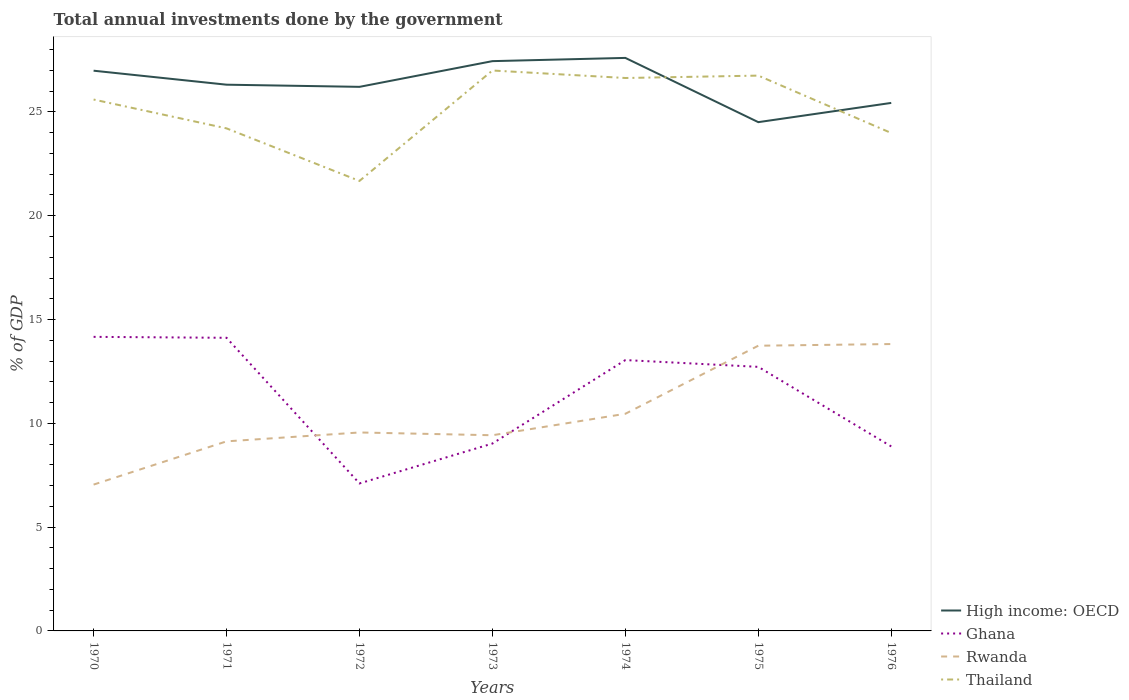Across all years, what is the maximum total annual investments done by the government in Rwanda?
Your response must be concise. 7.05. In which year was the total annual investments done by the government in High income: OECD maximum?
Your response must be concise. 1975. What is the total total annual investments done by the government in Rwanda in the graph?
Your response must be concise. -2.51. What is the difference between the highest and the second highest total annual investments done by the government in Thailand?
Make the answer very short. 5.32. What is the difference between the highest and the lowest total annual investments done by the government in Thailand?
Provide a succinct answer. 4. How many years are there in the graph?
Your response must be concise. 7. Are the values on the major ticks of Y-axis written in scientific E-notation?
Offer a very short reply. No. Does the graph contain grids?
Offer a very short reply. No. How many legend labels are there?
Provide a short and direct response. 4. How are the legend labels stacked?
Your answer should be compact. Vertical. What is the title of the graph?
Ensure brevity in your answer.  Total annual investments done by the government. What is the label or title of the Y-axis?
Your answer should be compact. % of GDP. What is the % of GDP of High income: OECD in 1970?
Your answer should be very brief. 26.99. What is the % of GDP in Ghana in 1970?
Give a very brief answer. 14.17. What is the % of GDP of Rwanda in 1970?
Make the answer very short. 7.05. What is the % of GDP in Thailand in 1970?
Give a very brief answer. 25.6. What is the % of GDP of High income: OECD in 1971?
Your response must be concise. 26.31. What is the % of GDP in Ghana in 1971?
Keep it short and to the point. 14.12. What is the % of GDP in Rwanda in 1971?
Your response must be concise. 9.13. What is the % of GDP of Thailand in 1971?
Ensure brevity in your answer.  24.21. What is the % of GDP of High income: OECD in 1972?
Your answer should be very brief. 26.21. What is the % of GDP of Ghana in 1972?
Provide a short and direct response. 7.1. What is the % of GDP in Rwanda in 1972?
Offer a terse response. 9.56. What is the % of GDP in Thailand in 1972?
Offer a terse response. 21.68. What is the % of GDP of High income: OECD in 1973?
Provide a succinct answer. 27.45. What is the % of GDP in Ghana in 1973?
Offer a terse response. 9.03. What is the % of GDP in Rwanda in 1973?
Ensure brevity in your answer.  9.43. What is the % of GDP in Thailand in 1973?
Your answer should be very brief. 27. What is the % of GDP in High income: OECD in 1974?
Offer a terse response. 27.6. What is the % of GDP in Ghana in 1974?
Ensure brevity in your answer.  13.05. What is the % of GDP of Rwanda in 1974?
Keep it short and to the point. 10.46. What is the % of GDP of Thailand in 1974?
Give a very brief answer. 26.64. What is the % of GDP of High income: OECD in 1975?
Provide a succinct answer. 24.51. What is the % of GDP of Ghana in 1975?
Your answer should be very brief. 12.72. What is the % of GDP in Rwanda in 1975?
Your answer should be very brief. 13.74. What is the % of GDP of Thailand in 1975?
Your answer should be very brief. 26.75. What is the % of GDP in High income: OECD in 1976?
Offer a very short reply. 25.43. What is the % of GDP of Ghana in 1976?
Your answer should be very brief. 8.89. What is the % of GDP of Rwanda in 1976?
Offer a terse response. 13.82. What is the % of GDP in Thailand in 1976?
Give a very brief answer. 23.99. Across all years, what is the maximum % of GDP of High income: OECD?
Give a very brief answer. 27.6. Across all years, what is the maximum % of GDP in Ghana?
Make the answer very short. 14.17. Across all years, what is the maximum % of GDP in Rwanda?
Offer a very short reply. 13.82. Across all years, what is the maximum % of GDP of Thailand?
Your response must be concise. 27. Across all years, what is the minimum % of GDP in High income: OECD?
Give a very brief answer. 24.51. Across all years, what is the minimum % of GDP in Ghana?
Provide a succinct answer. 7.1. Across all years, what is the minimum % of GDP of Rwanda?
Your answer should be compact. 7.05. Across all years, what is the minimum % of GDP of Thailand?
Your response must be concise. 21.68. What is the total % of GDP in High income: OECD in the graph?
Your answer should be compact. 184.5. What is the total % of GDP of Ghana in the graph?
Provide a short and direct response. 79.07. What is the total % of GDP of Rwanda in the graph?
Offer a very short reply. 73.18. What is the total % of GDP in Thailand in the graph?
Keep it short and to the point. 175.85. What is the difference between the % of GDP in High income: OECD in 1970 and that in 1971?
Offer a very short reply. 0.67. What is the difference between the % of GDP in Ghana in 1970 and that in 1971?
Offer a very short reply. 0.05. What is the difference between the % of GDP of Rwanda in 1970 and that in 1971?
Ensure brevity in your answer.  -2.08. What is the difference between the % of GDP in Thailand in 1970 and that in 1971?
Offer a very short reply. 1.39. What is the difference between the % of GDP in High income: OECD in 1970 and that in 1972?
Your answer should be very brief. 0.78. What is the difference between the % of GDP of Ghana in 1970 and that in 1972?
Your response must be concise. 7.06. What is the difference between the % of GDP of Rwanda in 1970 and that in 1972?
Provide a succinct answer. -2.51. What is the difference between the % of GDP in Thailand in 1970 and that in 1972?
Offer a terse response. 3.92. What is the difference between the % of GDP in High income: OECD in 1970 and that in 1973?
Provide a short and direct response. -0.46. What is the difference between the % of GDP of Ghana in 1970 and that in 1973?
Offer a very short reply. 5.14. What is the difference between the % of GDP of Rwanda in 1970 and that in 1973?
Give a very brief answer. -2.38. What is the difference between the % of GDP in Thailand in 1970 and that in 1973?
Your answer should be compact. -1.4. What is the difference between the % of GDP of High income: OECD in 1970 and that in 1974?
Your answer should be very brief. -0.62. What is the difference between the % of GDP in Ghana in 1970 and that in 1974?
Keep it short and to the point. 1.12. What is the difference between the % of GDP of Rwanda in 1970 and that in 1974?
Offer a terse response. -3.41. What is the difference between the % of GDP in Thailand in 1970 and that in 1974?
Your answer should be very brief. -1.04. What is the difference between the % of GDP in High income: OECD in 1970 and that in 1975?
Give a very brief answer. 2.48. What is the difference between the % of GDP of Ghana in 1970 and that in 1975?
Your response must be concise. 1.45. What is the difference between the % of GDP of Rwanda in 1970 and that in 1975?
Offer a terse response. -6.69. What is the difference between the % of GDP in Thailand in 1970 and that in 1975?
Your answer should be compact. -1.15. What is the difference between the % of GDP of High income: OECD in 1970 and that in 1976?
Provide a short and direct response. 1.55. What is the difference between the % of GDP of Ghana in 1970 and that in 1976?
Provide a succinct answer. 5.28. What is the difference between the % of GDP in Rwanda in 1970 and that in 1976?
Provide a short and direct response. -6.77. What is the difference between the % of GDP in Thailand in 1970 and that in 1976?
Keep it short and to the point. 1.61. What is the difference between the % of GDP of High income: OECD in 1971 and that in 1972?
Provide a short and direct response. 0.1. What is the difference between the % of GDP in Ghana in 1971 and that in 1972?
Keep it short and to the point. 7.02. What is the difference between the % of GDP in Rwanda in 1971 and that in 1972?
Your answer should be compact. -0.43. What is the difference between the % of GDP of Thailand in 1971 and that in 1972?
Give a very brief answer. 2.53. What is the difference between the % of GDP in High income: OECD in 1971 and that in 1973?
Your response must be concise. -1.13. What is the difference between the % of GDP in Ghana in 1971 and that in 1973?
Offer a very short reply. 5.09. What is the difference between the % of GDP of Rwanda in 1971 and that in 1973?
Provide a short and direct response. -0.29. What is the difference between the % of GDP in Thailand in 1971 and that in 1973?
Provide a succinct answer. -2.79. What is the difference between the % of GDP in High income: OECD in 1971 and that in 1974?
Offer a very short reply. -1.29. What is the difference between the % of GDP of Ghana in 1971 and that in 1974?
Provide a succinct answer. 1.07. What is the difference between the % of GDP of Rwanda in 1971 and that in 1974?
Ensure brevity in your answer.  -1.33. What is the difference between the % of GDP in Thailand in 1971 and that in 1974?
Provide a short and direct response. -2.43. What is the difference between the % of GDP in High income: OECD in 1971 and that in 1975?
Offer a very short reply. 1.8. What is the difference between the % of GDP of Rwanda in 1971 and that in 1975?
Keep it short and to the point. -4.61. What is the difference between the % of GDP of Thailand in 1971 and that in 1975?
Offer a terse response. -2.54. What is the difference between the % of GDP in High income: OECD in 1971 and that in 1976?
Your answer should be compact. 0.88. What is the difference between the % of GDP of Ghana in 1971 and that in 1976?
Provide a short and direct response. 5.23. What is the difference between the % of GDP of Rwanda in 1971 and that in 1976?
Your response must be concise. -4.69. What is the difference between the % of GDP of Thailand in 1971 and that in 1976?
Make the answer very short. 0.22. What is the difference between the % of GDP in High income: OECD in 1972 and that in 1973?
Make the answer very short. -1.24. What is the difference between the % of GDP in Ghana in 1972 and that in 1973?
Provide a succinct answer. -1.92. What is the difference between the % of GDP in Rwanda in 1972 and that in 1973?
Keep it short and to the point. 0.13. What is the difference between the % of GDP in Thailand in 1972 and that in 1973?
Make the answer very short. -5.32. What is the difference between the % of GDP in High income: OECD in 1972 and that in 1974?
Your answer should be compact. -1.39. What is the difference between the % of GDP of Ghana in 1972 and that in 1974?
Offer a very short reply. -5.94. What is the difference between the % of GDP in Rwanda in 1972 and that in 1974?
Provide a short and direct response. -0.9. What is the difference between the % of GDP in Thailand in 1972 and that in 1974?
Offer a terse response. -4.96. What is the difference between the % of GDP in High income: OECD in 1972 and that in 1975?
Your answer should be compact. 1.7. What is the difference between the % of GDP in Ghana in 1972 and that in 1975?
Your answer should be very brief. -5.62. What is the difference between the % of GDP of Rwanda in 1972 and that in 1975?
Give a very brief answer. -4.18. What is the difference between the % of GDP in Thailand in 1972 and that in 1975?
Provide a succinct answer. -5.07. What is the difference between the % of GDP of High income: OECD in 1972 and that in 1976?
Provide a short and direct response. 0.77. What is the difference between the % of GDP of Ghana in 1972 and that in 1976?
Provide a short and direct response. -1.78. What is the difference between the % of GDP of Rwanda in 1972 and that in 1976?
Ensure brevity in your answer.  -4.26. What is the difference between the % of GDP in Thailand in 1972 and that in 1976?
Keep it short and to the point. -2.31. What is the difference between the % of GDP of High income: OECD in 1973 and that in 1974?
Provide a short and direct response. -0.16. What is the difference between the % of GDP of Ghana in 1973 and that in 1974?
Ensure brevity in your answer.  -4.02. What is the difference between the % of GDP of Rwanda in 1973 and that in 1974?
Your answer should be very brief. -1.03. What is the difference between the % of GDP of Thailand in 1973 and that in 1974?
Provide a succinct answer. 0.36. What is the difference between the % of GDP in High income: OECD in 1973 and that in 1975?
Your answer should be compact. 2.94. What is the difference between the % of GDP of Ghana in 1973 and that in 1975?
Your response must be concise. -3.69. What is the difference between the % of GDP of Rwanda in 1973 and that in 1975?
Provide a succinct answer. -4.31. What is the difference between the % of GDP of Thailand in 1973 and that in 1975?
Offer a terse response. 0.25. What is the difference between the % of GDP of High income: OECD in 1973 and that in 1976?
Provide a short and direct response. 2.01. What is the difference between the % of GDP of Ghana in 1973 and that in 1976?
Provide a short and direct response. 0.14. What is the difference between the % of GDP in Rwanda in 1973 and that in 1976?
Your answer should be compact. -4.39. What is the difference between the % of GDP of Thailand in 1973 and that in 1976?
Offer a very short reply. 3.01. What is the difference between the % of GDP of High income: OECD in 1974 and that in 1975?
Give a very brief answer. 3.09. What is the difference between the % of GDP in Ghana in 1974 and that in 1975?
Provide a short and direct response. 0.33. What is the difference between the % of GDP in Rwanda in 1974 and that in 1975?
Your response must be concise. -3.28. What is the difference between the % of GDP in Thailand in 1974 and that in 1975?
Offer a very short reply. -0.12. What is the difference between the % of GDP in High income: OECD in 1974 and that in 1976?
Offer a terse response. 2.17. What is the difference between the % of GDP in Ghana in 1974 and that in 1976?
Keep it short and to the point. 4.16. What is the difference between the % of GDP in Rwanda in 1974 and that in 1976?
Make the answer very short. -3.36. What is the difference between the % of GDP in Thailand in 1974 and that in 1976?
Provide a succinct answer. 2.65. What is the difference between the % of GDP in High income: OECD in 1975 and that in 1976?
Offer a terse response. -0.93. What is the difference between the % of GDP of Ghana in 1975 and that in 1976?
Give a very brief answer. 3.83. What is the difference between the % of GDP in Rwanda in 1975 and that in 1976?
Offer a terse response. -0.08. What is the difference between the % of GDP of Thailand in 1975 and that in 1976?
Offer a terse response. 2.77. What is the difference between the % of GDP in High income: OECD in 1970 and the % of GDP in Ghana in 1971?
Keep it short and to the point. 12.87. What is the difference between the % of GDP in High income: OECD in 1970 and the % of GDP in Rwanda in 1971?
Provide a short and direct response. 17.86. What is the difference between the % of GDP of High income: OECD in 1970 and the % of GDP of Thailand in 1971?
Keep it short and to the point. 2.78. What is the difference between the % of GDP in Ghana in 1970 and the % of GDP in Rwanda in 1971?
Provide a succinct answer. 5.03. What is the difference between the % of GDP of Ghana in 1970 and the % of GDP of Thailand in 1971?
Keep it short and to the point. -10.04. What is the difference between the % of GDP in Rwanda in 1970 and the % of GDP in Thailand in 1971?
Keep it short and to the point. -17.16. What is the difference between the % of GDP of High income: OECD in 1970 and the % of GDP of Ghana in 1972?
Give a very brief answer. 19.88. What is the difference between the % of GDP in High income: OECD in 1970 and the % of GDP in Rwanda in 1972?
Keep it short and to the point. 17.43. What is the difference between the % of GDP in High income: OECD in 1970 and the % of GDP in Thailand in 1972?
Your response must be concise. 5.31. What is the difference between the % of GDP of Ghana in 1970 and the % of GDP of Rwanda in 1972?
Your answer should be very brief. 4.61. What is the difference between the % of GDP of Ghana in 1970 and the % of GDP of Thailand in 1972?
Your response must be concise. -7.51. What is the difference between the % of GDP of Rwanda in 1970 and the % of GDP of Thailand in 1972?
Provide a succinct answer. -14.63. What is the difference between the % of GDP in High income: OECD in 1970 and the % of GDP in Ghana in 1973?
Your answer should be very brief. 17.96. What is the difference between the % of GDP in High income: OECD in 1970 and the % of GDP in Rwanda in 1973?
Your answer should be compact. 17.56. What is the difference between the % of GDP of High income: OECD in 1970 and the % of GDP of Thailand in 1973?
Provide a succinct answer. -0.01. What is the difference between the % of GDP in Ghana in 1970 and the % of GDP in Rwanda in 1973?
Provide a succinct answer. 4.74. What is the difference between the % of GDP in Ghana in 1970 and the % of GDP in Thailand in 1973?
Give a very brief answer. -12.83. What is the difference between the % of GDP of Rwanda in 1970 and the % of GDP of Thailand in 1973?
Make the answer very short. -19.95. What is the difference between the % of GDP in High income: OECD in 1970 and the % of GDP in Ghana in 1974?
Offer a terse response. 13.94. What is the difference between the % of GDP in High income: OECD in 1970 and the % of GDP in Rwanda in 1974?
Provide a succinct answer. 16.53. What is the difference between the % of GDP of High income: OECD in 1970 and the % of GDP of Thailand in 1974?
Offer a very short reply. 0.35. What is the difference between the % of GDP in Ghana in 1970 and the % of GDP in Rwanda in 1974?
Offer a very short reply. 3.71. What is the difference between the % of GDP in Ghana in 1970 and the % of GDP in Thailand in 1974?
Keep it short and to the point. -12.47. What is the difference between the % of GDP of Rwanda in 1970 and the % of GDP of Thailand in 1974?
Make the answer very short. -19.59. What is the difference between the % of GDP in High income: OECD in 1970 and the % of GDP in Ghana in 1975?
Keep it short and to the point. 14.27. What is the difference between the % of GDP of High income: OECD in 1970 and the % of GDP of Rwanda in 1975?
Offer a very short reply. 13.25. What is the difference between the % of GDP in High income: OECD in 1970 and the % of GDP in Thailand in 1975?
Offer a terse response. 0.24. What is the difference between the % of GDP of Ghana in 1970 and the % of GDP of Rwanda in 1975?
Make the answer very short. 0.43. What is the difference between the % of GDP of Ghana in 1970 and the % of GDP of Thailand in 1975?
Offer a very short reply. -12.58. What is the difference between the % of GDP in Rwanda in 1970 and the % of GDP in Thailand in 1975?
Keep it short and to the point. -19.7. What is the difference between the % of GDP of High income: OECD in 1970 and the % of GDP of Ghana in 1976?
Offer a very short reply. 18.1. What is the difference between the % of GDP of High income: OECD in 1970 and the % of GDP of Rwanda in 1976?
Offer a terse response. 13.17. What is the difference between the % of GDP in High income: OECD in 1970 and the % of GDP in Thailand in 1976?
Your answer should be compact. 3. What is the difference between the % of GDP in Ghana in 1970 and the % of GDP in Rwanda in 1976?
Offer a very short reply. 0.35. What is the difference between the % of GDP of Ghana in 1970 and the % of GDP of Thailand in 1976?
Your answer should be very brief. -9.82. What is the difference between the % of GDP of Rwanda in 1970 and the % of GDP of Thailand in 1976?
Give a very brief answer. -16.94. What is the difference between the % of GDP in High income: OECD in 1971 and the % of GDP in Ghana in 1972?
Provide a short and direct response. 19.21. What is the difference between the % of GDP of High income: OECD in 1971 and the % of GDP of Rwanda in 1972?
Give a very brief answer. 16.75. What is the difference between the % of GDP in High income: OECD in 1971 and the % of GDP in Thailand in 1972?
Offer a terse response. 4.64. What is the difference between the % of GDP of Ghana in 1971 and the % of GDP of Rwanda in 1972?
Your answer should be very brief. 4.56. What is the difference between the % of GDP in Ghana in 1971 and the % of GDP in Thailand in 1972?
Provide a succinct answer. -7.56. What is the difference between the % of GDP of Rwanda in 1971 and the % of GDP of Thailand in 1972?
Offer a terse response. -12.54. What is the difference between the % of GDP of High income: OECD in 1971 and the % of GDP of Ghana in 1973?
Provide a succinct answer. 17.29. What is the difference between the % of GDP in High income: OECD in 1971 and the % of GDP in Rwanda in 1973?
Offer a terse response. 16.89. What is the difference between the % of GDP of High income: OECD in 1971 and the % of GDP of Thailand in 1973?
Keep it short and to the point. -0.68. What is the difference between the % of GDP of Ghana in 1971 and the % of GDP of Rwanda in 1973?
Provide a succinct answer. 4.69. What is the difference between the % of GDP of Ghana in 1971 and the % of GDP of Thailand in 1973?
Your answer should be compact. -12.88. What is the difference between the % of GDP in Rwanda in 1971 and the % of GDP in Thailand in 1973?
Keep it short and to the point. -17.86. What is the difference between the % of GDP of High income: OECD in 1971 and the % of GDP of Ghana in 1974?
Offer a terse response. 13.27. What is the difference between the % of GDP in High income: OECD in 1971 and the % of GDP in Rwanda in 1974?
Ensure brevity in your answer.  15.85. What is the difference between the % of GDP of High income: OECD in 1971 and the % of GDP of Thailand in 1974?
Offer a very short reply. -0.32. What is the difference between the % of GDP in Ghana in 1971 and the % of GDP in Rwanda in 1974?
Keep it short and to the point. 3.66. What is the difference between the % of GDP in Ghana in 1971 and the % of GDP in Thailand in 1974?
Your response must be concise. -12.52. What is the difference between the % of GDP in Rwanda in 1971 and the % of GDP in Thailand in 1974?
Offer a terse response. -17.5. What is the difference between the % of GDP in High income: OECD in 1971 and the % of GDP in Ghana in 1975?
Your response must be concise. 13.59. What is the difference between the % of GDP in High income: OECD in 1971 and the % of GDP in Rwanda in 1975?
Keep it short and to the point. 12.57. What is the difference between the % of GDP of High income: OECD in 1971 and the % of GDP of Thailand in 1975?
Your response must be concise. -0.44. What is the difference between the % of GDP in Ghana in 1971 and the % of GDP in Rwanda in 1975?
Your answer should be compact. 0.38. What is the difference between the % of GDP in Ghana in 1971 and the % of GDP in Thailand in 1975?
Your response must be concise. -12.63. What is the difference between the % of GDP in Rwanda in 1971 and the % of GDP in Thailand in 1975?
Offer a very short reply. -17.62. What is the difference between the % of GDP of High income: OECD in 1971 and the % of GDP of Ghana in 1976?
Give a very brief answer. 17.43. What is the difference between the % of GDP in High income: OECD in 1971 and the % of GDP in Rwanda in 1976?
Provide a succinct answer. 12.49. What is the difference between the % of GDP of High income: OECD in 1971 and the % of GDP of Thailand in 1976?
Keep it short and to the point. 2.33. What is the difference between the % of GDP of Ghana in 1971 and the % of GDP of Rwanda in 1976?
Your answer should be compact. 0.3. What is the difference between the % of GDP of Ghana in 1971 and the % of GDP of Thailand in 1976?
Ensure brevity in your answer.  -9.87. What is the difference between the % of GDP in Rwanda in 1971 and the % of GDP in Thailand in 1976?
Give a very brief answer. -14.85. What is the difference between the % of GDP in High income: OECD in 1972 and the % of GDP in Ghana in 1973?
Provide a succinct answer. 17.18. What is the difference between the % of GDP of High income: OECD in 1972 and the % of GDP of Rwanda in 1973?
Give a very brief answer. 16.78. What is the difference between the % of GDP of High income: OECD in 1972 and the % of GDP of Thailand in 1973?
Your answer should be compact. -0.79. What is the difference between the % of GDP in Ghana in 1972 and the % of GDP in Rwanda in 1973?
Your answer should be compact. -2.32. What is the difference between the % of GDP in Ghana in 1972 and the % of GDP in Thailand in 1973?
Keep it short and to the point. -19.89. What is the difference between the % of GDP in Rwanda in 1972 and the % of GDP in Thailand in 1973?
Provide a short and direct response. -17.44. What is the difference between the % of GDP of High income: OECD in 1972 and the % of GDP of Ghana in 1974?
Your answer should be very brief. 13.16. What is the difference between the % of GDP of High income: OECD in 1972 and the % of GDP of Rwanda in 1974?
Your answer should be very brief. 15.75. What is the difference between the % of GDP of High income: OECD in 1972 and the % of GDP of Thailand in 1974?
Provide a short and direct response. -0.43. What is the difference between the % of GDP in Ghana in 1972 and the % of GDP in Rwanda in 1974?
Your answer should be very brief. -3.36. What is the difference between the % of GDP in Ghana in 1972 and the % of GDP in Thailand in 1974?
Your answer should be very brief. -19.53. What is the difference between the % of GDP of Rwanda in 1972 and the % of GDP of Thailand in 1974?
Offer a very short reply. -17.08. What is the difference between the % of GDP in High income: OECD in 1972 and the % of GDP in Ghana in 1975?
Provide a short and direct response. 13.49. What is the difference between the % of GDP of High income: OECD in 1972 and the % of GDP of Rwanda in 1975?
Keep it short and to the point. 12.47. What is the difference between the % of GDP of High income: OECD in 1972 and the % of GDP of Thailand in 1975?
Offer a very short reply. -0.54. What is the difference between the % of GDP of Ghana in 1972 and the % of GDP of Rwanda in 1975?
Make the answer very short. -6.63. What is the difference between the % of GDP of Ghana in 1972 and the % of GDP of Thailand in 1975?
Keep it short and to the point. -19.65. What is the difference between the % of GDP in Rwanda in 1972 and the % of GDP in Thailand in 1975?
Ensure brevity in your answer.  -17.19. What is the difference between the % of GDP of High income: OECD in 1972 and the % of GDP of Ghana in 1976?
Your response must be concise. 17.32. What is the difference between the % of GDP in High income: OECD in 1972 and the % of GDP in Rwanda in 1976?
Give a very brief answer. 12.39. What is the difference between the % of GDP of High income: OECD in 1972 and the % of GDP of Thailand in 1976?
Give a very brief answer. 2.22. What is the difference between the % of GDP of Ghana in 1972 and the % of GDP of Rwanda in 1976?
Your answer should be very brief. -6.71. What is the difference between the % of GDP in Ghana in 1972 and the % of GDP in Thailand in 1976?
Provide a succinct answer. -16.88. What is the difference between the % of GDP in Rwanda in 1972 and the % of GDP in Thailand in 1976?
Offer a very short reply. -14.43. What is the difference between the % of GDP of High income: OECD in 1973 and the % of GDP of Ghana in 1974?
Ensure brevity in your answer.  14.4. What is the difference between the % of GDP in High income: OECD in 1973 and the % of GDP in Rwanda in 1974?
Make the answer very short. 16.99. What is the difference between the % of GDP of High income: OECD in 1973 and the % of GDP of Thailand in 1974?
Your answer should be compact. 0.81. What is the difference between the % of GDP in Ghana in 1973 and the % of GDP in Rwanda in 1974?
Provide a short and direct response. -1.43. What is the difference between the % of GDP in Ghana in 1973 and the % of GDP in Thailand in 1974?
Your answer should be compact. -17.61. What is the difference between the % of GDP in Rwanda in 1973 and the % of GDP in Thailand in 1974?
Ensure brevity in your answer.  -17.21. What is the difference between the % of GDP in High income: OECD in 1973 and the % of GDP in Ghana in 1975?
Your answer should be compact. 14.73. What is the difference between the % of GDP of High income: OECD in 1973 and the % of GDP of Rwanda in 1975?
Your answer should be very brief. 13.71. What is the difference between the % of GDP in High income: OECD in 1973 and the % of GDP in Thailand in 1975?
Offer a terse response. 0.7. What is the difference between the % of GDP of Ghana in 1973 and the % of GDP of Rwanda in 1975?
Keep it short and to the point. -4.71. What is the difference between the % of GDP of Ghana in 1973 and the % of GDP of Thailand in 1975?
Offer a terse response. -17.72. What is the difference between the % of GDP of Rwanda in 1973 and the % of GDP of Thailand in 1975?
Offer a very short reply. -17.32. What is the difference between the % of GDP in High income: OECD in 1973 and the % of GDP in Ghana in 1976?
Make the answer very short. 18.56. What is the difference between the % of GDP in High income: OECD in 1973 and the % of GDP in Rwanda in 1976?
Your response must be concise. 13.63. What is the difference between the % of GDP of High income: OECD in 1973 and the % of GDP of Thailand in 1976?
Provide a succinct answer. 3.46. What is the difference between the % of GDP of Ghana in 1973 and the % of GDP of Rwanda in 1976?
Keep it short and to the point. -4.79. What is the difference between the % of GDP of Ghana in 1973 and the % of GDP of Thailand in 1976?
Offer a terse response. -14.96. What is the difference between the % of GDP of Rwanda in 1973 and the % of GDP of Thailand in 1976?
Make the answer very short. -14.56. What is the difference between the % of GDP in High income: OECD in 1974 and the % of GDP in Ghana in 1975?
Provide a succinct answer. 14.88. What is the difference between the % of GDP of High income: OECD in 1974 and the % of GDP of Rwanda in 1975?
Give a very brief answer. 13.86. What is the difference between the % of GDP of High income: OECD in 1974 and the % of GDP of Thailand in 1975?
Your answer should be compact. 0.85. What is the difference between the % of GDP of Ghana in 1974 and the % of GDP of Rwanda in 1975?
Make the answer very short. -0.69. What is the difference between the % of GDP of Ghana in 1974 and the % of GDP of Thailand in 1975?
Your response must be concise. -13.7. What is the difference between the % of GDP of Rwanda in 1974 and the % of GDP of Thailand in 1975?
Your answer should be very brief. -16.29. What is the difference between the % of GDP in High income: OECD in 1974 and the % of GDP in Ghana in 1976?
Offer a very short reply. 18.72. What is the difference between the % of GDP of High income: OECD in 1974 and the % of GDP of Rwanda in 1976?
Give a very brief answer. 13.78. What is the difference between the % of GDP in High income: OECD in 1974 and the % of GDP in Thailand in 1976?
Keep it short and to the point. 3.62. What is the difference between the % of GDP of Ghana in 1974 and the % of GDP of Rwanda in 1976?
Give a very brief answer. -0.77. What is the difference between the % of GDP of Ghana in 1974 and the % of GDP of Thailand in 1976?
Provide a short and direct response. -10.94. What is the difference between the % of GDP of Rwanda in 1974 and the % of GDP of Thailand in 1976?
Give a very brief answer. -13.53. What is the difference between the % of GDP of High income: OECD in 1975 and the % of GDP of Ghana in 1976?
Your response must be concise. 15.62. What is the difference between the % of GDP in High income: OECD in 1975 and the % of GDP in Rwanda in 1976?
Offer a terse response. 10.69. What is the difference between the % of GDP of High income: OECD in 1975 and the % of GDP of Thailand in 1976?
Keep it short and to the point. 0.52. What is the difference between the % of GDP of Ghana in 1975 and the % of GDP of Rwanda in 1976?
Give a very brief answer. -1.1. What is the difference between the % of GDP in Ghana in 1975 and the % of GDP in Thailand in 1976?
Give a very brief answer. -11.27. What is the difference between the % of GDP in Rwanda in 1975 and the % of GDP in Thailand in 1976?
Make the answer very short. -10.25. What is the average % of GDP in High income: OECD per year?
Provide a succinct answer. 26.36. What is the average % of GDP of Ghana per year?
Make the answer very short. 11.3. What is the average % of GDP in Rwanda per year?
Provide a short and direct response. 10.45. What is the average % of GDP in Thailand per year?
Offer a very short reply. 25.12. In the year 1970, what is the difference between the % of GDP in High income: OECD and % of GDP in Ghana?
Keep it short and to the point. 12.82. In the year 1970, what is the difference between the % of GDP of High income: OECD and % of GDP of Rwanda?
Your answer should be compact. 19.94. In the year 1970, what is the difference between the % of GDP of High income: OECD and % of GDP of Thailand?
Make the answer very short. 1.39. In the year 1970, what is the difference between the % of GDP of Ghana and % of GDP of Rwanda?
Give a very brief answer. 7.12. In the year 1970, what is the difference between the % of GDP in Ghana and % of GDP in Thailand?
Give a very brief answer. -11.43. In the year 1970, what is the difference between the % of GDP of Rwanda and % of GDP of Thailand?
Your response must be concise. -18.55. In the year 1971, what is the difference between the % of GDP in High income: OECD and % of GDP in Ghana?
Your answer should be very brief. 12.19. In the year 1971, what is the difference between the % of GDP in High income: OECD and % of GDP in Rwanda?
Offer a very short reply. 17.18. In the year 1971, what is the difference between the % of GDP in High income: OECD and % of GDP in Thailand?
Provide a short and direct response. 2.1. In the year 1971, what is the difference between the % of GDP in Ghana and % of GDP in Rwanda?
Your response must be concise. 4.99. In the year 1971, what is the difference between the % of GDP in Ghana and % of GDP in Thailand?
Your response must be concise. -10.09. In the year 1971, what is the difference between the % of GDP of Rwanda and % of GDP of Thailand?
Offer a very short reply. -15.08. In the year 1972, what is the difference between the % of GDP of High income: OECD and % of GDP of Ghana?
Provide a short and direct response. 19.1. In the year 1972, what is the difference between the % of GDP in High income: OECD and % of GDP in Rwanda?
Provide a succinct answer. 16.65. In the year 1972, what is the difference between the % of GDP in High income: OECD and % of GDP in Thailand?
Provide a short and direct response. 4.53. In the year 1972, what is the difference between the % of GDP in Ghana and % of GDP in Rwanda?
Your answer should be compact. -2.45. In the year 1972, what is the difference between the % of GDP of Ghana and % of GDP of Thailand?
Provide a short and direct response. -14.57. In the year 1972, what is the difference between the % of GDP in Rwanda and % of GDP in Thailand?
Provide a short and direct response. -12.12. In the year 1973, what is the difference between the % of GDP in High income: OECD and % of GDP in Ghana?
Provide a short and direct response. 18.42. In the year 1973, what is the difference between the % of GDP in High income: OECD and % of GDP in Rwanda?
Your answer should be compact. 18.02. In the year 1973, what is the difference between the % of GDP in High income: OECD and % of GDP in Thailand?
Give a very brief answer. 0.45. In the year 1973, what is the difference between the % of GDP in Ghana and % of GDP in Rwanda?
Offer a terse response. -0.4. In the year 1973, what is the difference between the % of GDP in Ghana and % of GDP in Thailand?
Your answer should be very brief. -17.97. In the year 1973, what is the difference between the % of GDP in Rwanda and % of GDP in Thailand?
Your response must be concise. -17.57. In the year 1974, what is the difference between the % of GDP in High income: OECD and % of GDP in Ghana?
Your answer should be very brief. 14.56. In the year 1974, what is the difference between the % of GDP in High income: OECD and % of GDP in Rwanda?
Offer a very short reply. 17.14. In the year 1974, what is the difference between the % of GDP of High income: OECD and % of GDP of Thailand?
Offer a terse response. 0.97. In the year 1974, what is the difference between the % of GDP of Ghana and % of GDP of Rwanda?
Your answer should be very brief. 2.59. In the year 1974, what is the difference between the % of GDP of Ghana and % of GDP of Thailand?
Ensure brevity in your answer.  -13.59. In the year 1974, what is the difference between the % of GDP of Rwanda and % of GDP of Thailand?
Give a very brief answer. -16.17. In the year 1975, what is the difference between the % of GDP of High income: OECD and % of GDP of Ghana?
Your answer should be very brief. 11.79. In the year 1975, what is the difference between the % of GDP of High income: OECD and % of GDP of Rwanda?
Offer a very short reply. 10.77. In the year 1975, what is the difference between the % of GDP of High income: OECD and % of GDP of Thailand?
Ensure brevity in your answer.  -2.24. In the year 1975, what is the difference between the % of GDP of Ghana and % of GDP of Rwanda?
Give a very brief answer. -1.02. In the year 1975, what is the difference between the % of GDP in Ghana and % of GDP in Thailand?
Ensure brevity in your answer.  -14.03. In the year 1975, what is the difference between the % of GDP of Rwanda and % of GDP of Thailand?
Ensure brevity in your answer.  -13.01. In the year 1976, what is the difference between the % of GDP of High income: OECD and % of GDP of Ghana?
Offer a very short reply. 16.55. In the year 1976, what is the difference between the % of GDP of High income: OECD and % of GDP of Rwanda?
Offer a very short reply. 11.62. In the year 1976, what is the difference between the % of GDP in High income: OECD and % of GDP in Thailand?
Offer a terse response. 1.45. In the year 1976, what is the difference between the % of GDP of Ghana and % of GDP of Rwanda?
Make the answer very short. -4.93. In the year 1976, what is the difference between the % of GDP in Ghana and % of GDP in Thailand?
Give a very brief answer. -15.1. In the year 1976, what is the difference between the % of GDP of Rwanda and % of GDP of Thailand?
Your answer should be compact. -10.17. What is the ratio of the % of GDP in High income: OECD in 1970 to that in 1971?
Your response must be concise. 1.03. What is the ratio of the % of GDP in Ghana in 1970 to that in 1971?
Your answer should be compact. 1. What is the ratio of the % of GDP in Rwanda in 1970 to that in 1971?
Provide a short and direct response. 0.77. What is the ratio of the % of GDP in Thailand in 1970 to that in 1971?
Your response must be concise. 1.06. What is the ratio of the % of GDP in High income: OECD in 1970 to that in 1972?
Ensure brevity in your answer.  1.03. What is the ratio of the % of GDP of Ghana in 1970 to that in 1972?
Offer a very short reply. 1.99. What is the ratio of the % of GDP of Rwanda in 1970 to that in 1972?
Keep it short and to the point. 0.74. What is the ratio of the % of GDP in Thailand in 1970 to that in 1972?
Make the answer very short. 1.18. What is the ratio of the % of GDP of High income: OECD in 1970 to that in 1973?
Ensure brevity in your answer.  0.98. What is the ratio of the % of GDP in Ghana in 1970 to that in 1973?
Offer a very short reply. 1.57. What is the ratio of the % of GDP in Rwanda in 1970 to that in 1973?
Ensure brevity in your answer.  0.75. What is the ratio of the % of GDP in Thailand in 1970 to that in 1973?
Your answer should be very brief. 0.95. What is the ratio of the % of GDP of High income: OECD in 1970 to that in 1974?
Offer a terse response. 0.98. What is the ratio of the % of GDP in Ghana in 1970 to that in 1974?
Your answer should be compact. 1.09. What is the ratio of the % of GDP in Rwanda in 1970 to that in 1974?
Make the answer very short. 0.67. What is the ratio of the % of GDP of Thailand in 1970 to that in 1974?
Your answer should be compact. 0.96. What is the ratio of the % of GDP of High income: OECD in 1970 to that in 1975?
Your answer should be compact. 1.1. What is the ratio of the % of GDP in Ghana in 1970 to that in 1975?
Your answer should be compact. 1.11. What is the ratio of the % of GDP in Rwanda in 1970 to that in 1975?
Give a very brief answer. 0.51. What is the ratio of the % of GDP of Thailand in 1970 to that in 1975?
Your response must be concise. 0.96. What is the ratio of the % of GDP in High income: OECD in 1970 to that in 1976?
Your answer should be very brief. 1.06. What is the ratio of the % of GDP of Ghana in 1970 to that in 1976?
Provide a short and direct response. 1.59. What is the ratio of the % of GDP in Rwanda in 1970 to that in 1976?
Provide a short and direct response. 0.51. What is the ratio of the % of GDP of Thailand in 1970 to that in 1976?
Your answer should be compact. 1.07. What is the ratio of the % of GDP of High income: OECD in 1971 to that in 1972?
Your answer should be very brief. 1. What is the ratio of the % of GDP in Ghana in 1971 to that in 1972?
Your answer should be compact. 1.99. What is the ratio of the % of GDP of Rwanda in 1971 to that in 1972?
Offer a terse response. 0.96. What is the ratio of the % of GDP of Thailand in 1971 to that in 1972?
Your response must be concise. 1.12. What is the ratio of the % of GDP in High income: OECD in 1971 to that in 1973?
Keep it short and to the point. 0.96. What is the ratio of the % of GDP in Ghana in 1971 to that in 1973?
Keep it short and to the point. 1.56. What is the ratio of the % of GDP in Rwanda in 1971 to that in 1973?
Your response must be concise. 0.97. What is the ratio of the % of GDP in Thailand in 1971 to that in 1973?
Make the answer very short. 0.9. What is the ratio of the % of GDP in High income: OECD in 1971 to that in 1974?
Provide a short and direct response. 0.95. What is the ratio of the % of GDP in Ghana in 1971 to that in 1974?
Provide a succinct answer. 1.08. What is the ratio of the % of GDP of Rwanda in 1971 to that in 1974?
Provide a short and direct response. 0.87. What is the ratio of the % of GDP of Thailand in 1971 to that in 1974?
Offer a very short reply. 0.91. What is the ratio of the % of GDP of High income: OECD in 1971 to that in 1975?
Offer a very short reply. 1.07. What is the ratio of the % of GDP of Ghana in 1971 to that in 1975?
Your response must be concise. 1.11. What is the ratio of the % of GDP in Rwanda in 1971 to that in 1975?
Your answer should be very brief. 0.66. What is the ratio of the % of GDP in Thailand in 1971 to that in 1975?
Offer a very short reply. 0.91. What is the ratio of the % of GDP in High income: OECD in 1971 to that in 1976?
Your answer should be compact. 1.03. What is the ratio of the % of GDP in Ghana in 1971 to that in 1976?
Your answer should be compact. 1.59. What is the ratio of the % of GDP in Rwanda in 1971 to that in 1976?
Provide a succinct answer. 0.66. What is the ratio of the % of GDP in Thailand in 1971 to that in 1976?
Keep it short and to the point. 1.01. What is the ratio of the % of GDP in High income: OECD in 1972 to that in 1973?
Make the answer very short. 0.95. What is the ratio of the % of GDP of Ghana in 1972 to that in 1973?
Offer a terse response. 0.79. What is the ratio of the % of GDP of Rwanda in 1972 to that in 1973?
Offer a terse response. 1.01. What is the ratio of the % of GDP of Thailand in 1972 to that in 1973?
Provide a short and direct response. 0.8. What is the ratio of the % of GDP in High income: OECD in 1972 to that in 1974?
Give a very brief answer. 0.95. What is the ratio of the % of GDP of Ghana in 1972 to that in 1974?
Provide a short and direct response. 0.54. What is the ratio of the % of GDP in Rwanda in 1972 to that in 1974?
Provide a succinct answer. 0.91. What is the ratio of the % of GDP of Thailand in 1972 to that in 1974?
Make the answer very short. 0.81. What is the ratio of the % of GDP in High income: OECD in 1972 to that in 1975?
Provide a succinct answer. 1.07. What is the ratio of the % of GDP in Ghana in 1972 to that in 1975?
Make the answer very short. 0.56. What is the ratio of the % of GDP in Rwanda in 1972 to that in 1975?
Offer a terse response. 0.7. What is the ratio of the % of GDP in Thailand in 1972 to that in 1975?
Offer a very short reply. 0.81. What is the ratio of the % of GDP in High income: OECD in 1972 to that in 1976?
Offer a terse response. 1.03. What is the ratio of the % of GDP in Ghana in 1972 to that in 1976?
Provide a short and direct response. 0.8. What is the ratio of the % of GDP in Rwanda in 1972 to that in 1976?
Provide a succinct answer. 0.69. What is the ratio of the % of GDP of Thailand in 1972 to that in 1976?
Make the answer very short. 0.9. What is the ratio of the % of GDP of Ghana in 1973 to that in 1974?
Make the answer very short. 0.69. What is the ratio of the % of GDP of Rwanda in 1973 to that in 1974?
Your response must be concise. 0.9. What is the ratio of the % of GDP of Thailand in 1973 to that in 1974?
Provide a short and direct response. 1.01. What is the ratio of the % of GDP in High income: OECD in 1973 to that in 1975?
Offer a terse response. 1.12. What is the ratio of the % of GDP of Ghana in 1973 to that in 1975?
Give a very brief answer. 0.71. What is the ratio of the % of GDP of Rwanda in 1973 to that in 1975?
Your response must be concise. 0.69. What is the ratio of the % of GDP of Thailand in 1973 to that in 1975?
Make the answer very short. 1.01. What is the ratio of the % of GDP of High income: OECD in 1973 to that in 1976?
Offer a terse response. 1.08. What is the ratio of the % of GDP in Ghana in 1973 to that in 1976?
Keep it short and to the point. 1.02. What is the ratio of the % of GDP in Rwanda in 1973 to that in 1976?
Your answer should be very brief. 0.68. What is the ratio of the % of GDP of Thailand in 1973 to that in 1976?
Ensure brevity in your answer.  1.13. What is the ratio of the % of GDP in High income: OECD in 1974 to that in 1975?
Offer a very short reply. 1.13. What is the ratio of the % of GDP of Ghana in 1974 to that in 1975?
Give a very brief answer. 1.03. What is the ratio of the % of GDP of Rwanda in 1974 to that in 1975?
Keep it short and to the point. 0.76. What is the ratio of the % of GDP of High income: OECD in 1974 to that in 1976?
Give a very brief answer. 1.09. What is the ratio of the % of GDP in Ghana in 1974 to that in 1976?
Make the answer very short. 1.47. What is the ratio of the % of GDP of Rwanda in 1974 to that in 1976?
Provide a succinct answer. 0.76. What is the ratio of the % of GDP of Thailand in 1974 to that in 1976?
Give a very brief answer. 1.11. What is the ratio of the % of GDP in High income: OECD in 1975 to that in 1976?
Keep it short and to the point. 0.96. What is the ratio of the % of GDP in Ghana in 1975 to that in 1976?
Give a very brief answer. 1.43. What is the ratio of the % of GDP of Rwanda in 1975 to that in 1976?
Provide a succinct answer. 0.99. What is the ratio of the % of GDP in Thailand in 1975 to that in 1976?
Your response must be concise. 1.12. What is the difference between the highest and the second highest % of GDP in High income: OECD?
Your answer should be very brief. 0.16. What is the difference between the highest and the second highest % of GDP of Ghana?
Provide a short and direct response. 0.05. What is the difference between the highest and the second highest % of GDP of Rwanda?
Ensure brevity in your answer.  0.08. What is the difference between the highest and the second highest % of GDP in Thailand?
Your response must be concise. 0.25. What is the difference between the highest and the lowest % of GDP in High income: OECD?
Provide a succinct answer. 3.09. What is the difference between the highest and the lowest % of GDP in Ghana?
Make the answer very short. 7.06. What is the difference between the highest and the lowest % of GDP of Rwanda?
Give a very brief answer. 6.77. What is the difference between the highest and the lowest % of GDP of Thailand?
Your answer should be very brief. 5.32. 